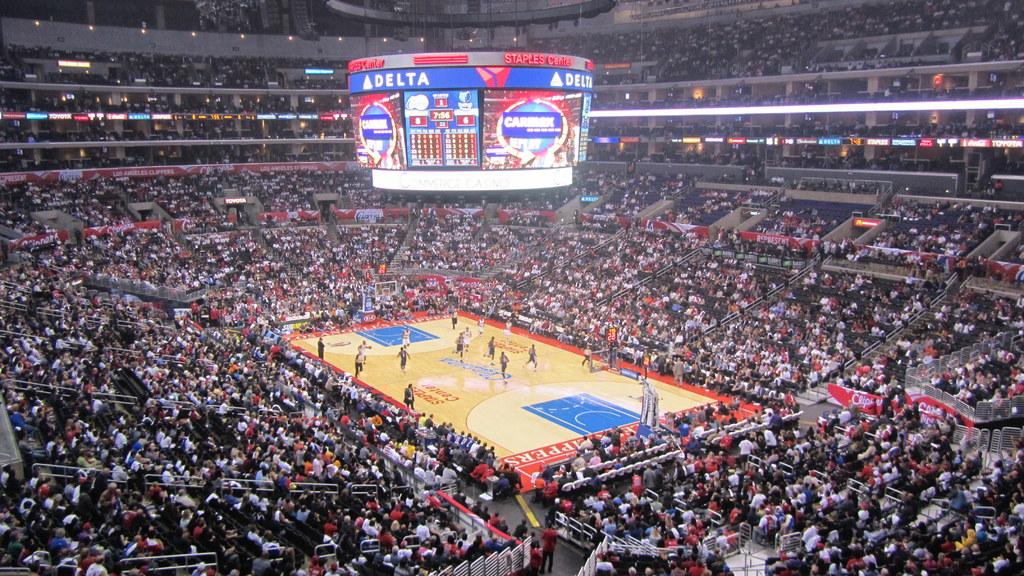What airlines is advertised on the big screen?
Ensure brevity in your answer.  Delta. What is the name of the stadium?
Ensure brevity in your answer.  Staples center. 